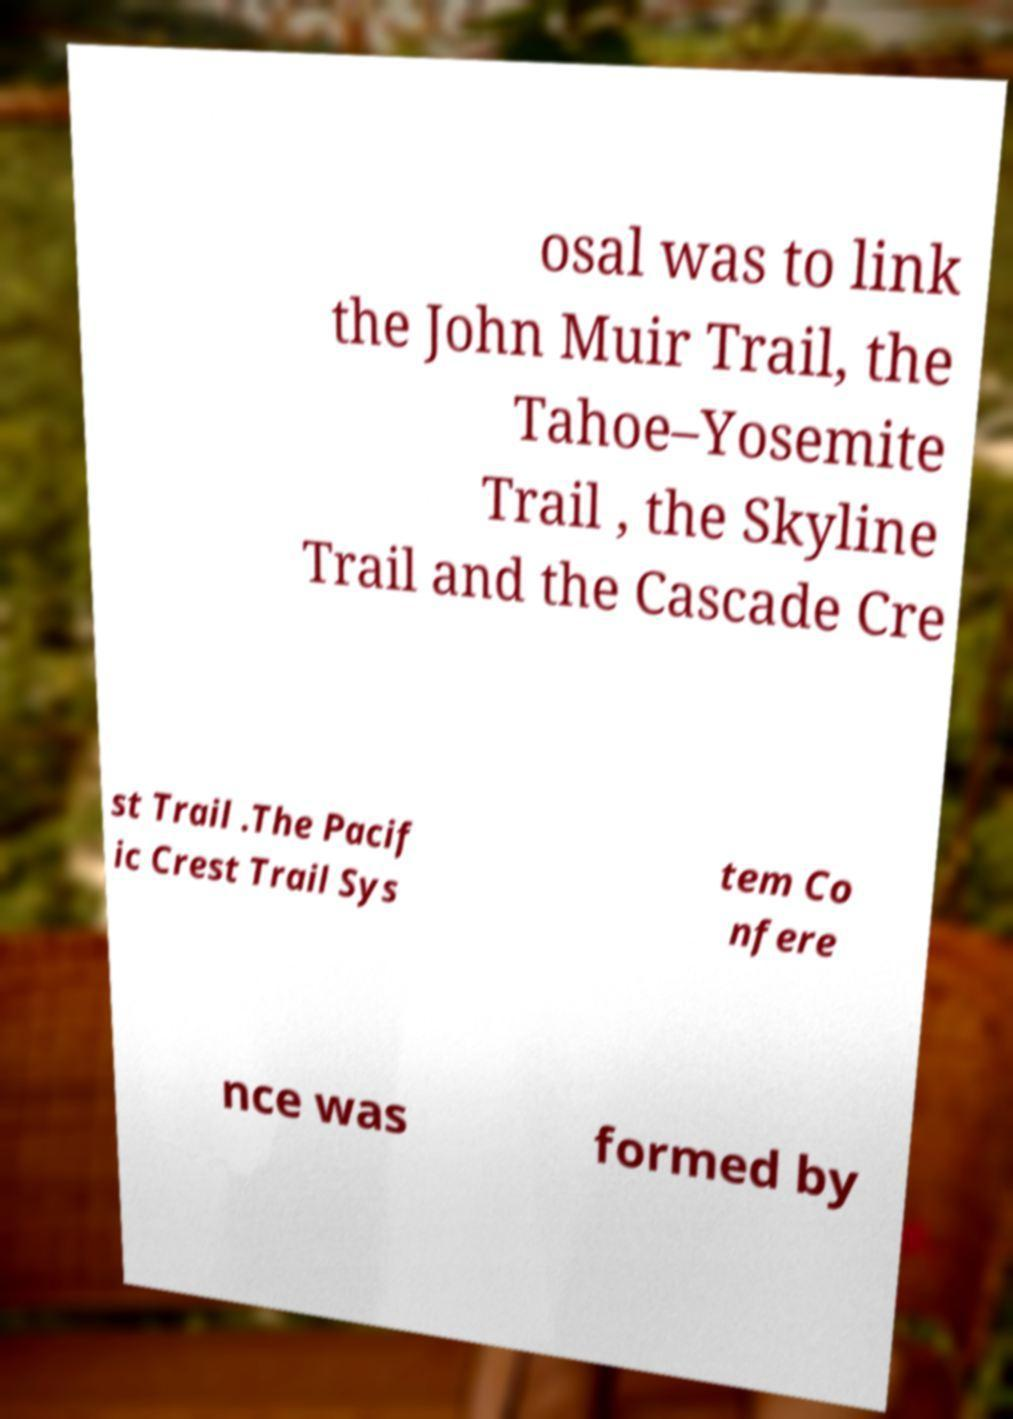I need the written content from this picture converted into text. Can you do that? osal was to link the John Muir Trail, the Tahoe–Yosemite Trail , the Skyline Trail and the Cascade Cre st Trail .The Pacif ic Crest Trail Sys tem Co nfere nce was formed by 